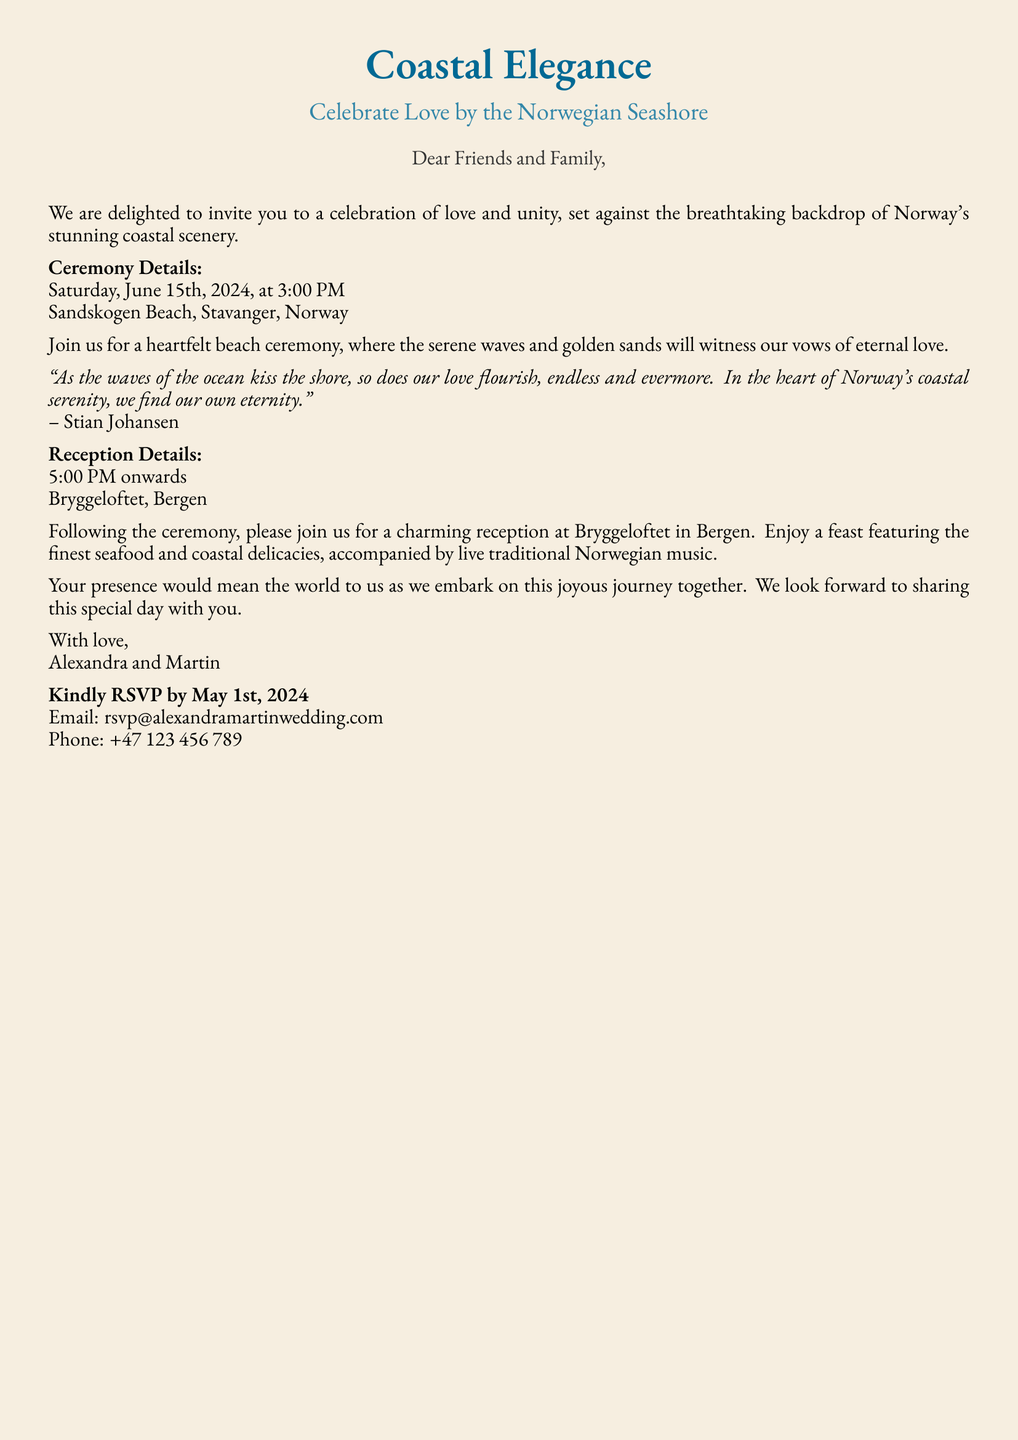What is the date of the wedding ceremony? The date is explicitly mentioned in the document as Saturday, June 15th, 2024.
Answer: June 15th, 2024 What time does the ceremony start? The starting time of the ceremony is stated clearly as 3:00 PM.
Answer: 3:00 PM Where is the wedding ceremony taking place? The location of the ceremony is given as Sandskogen Beach, Stavanger, Norway.
Answer: Sandskogen Beach, Stavanger, Norway What is the reception location? The document specifies that the reception will be held at Bryggeloftet, Bergen.
Answer: Bryggeloftet, Bergen What type of cuisine will be served at the reception? The invitation mentions a feast featuring the finest seafood and coastal delicacies.
Answer: Seafood and coastal delicacies Who are the hosts of the wedding? The invitation clearly states that the wedding is hosted by Alexandra and Martin.
Answer: Alexandra and Martin What should guests do by May 1st, 2024? The document requests guests to RSVP by this date.
Answer: RSVP by May 1st, 2024 What literary style is used in the invitation? The invitation includes nature-inspired prose, which enhances the theme.
Answer: Nature-inspired prose In what setting is the wedding ceremony described? The ceremony is described as taking place against the backdrop of Norway's stunning coastal scenery.
Answer: Coastal scenery 